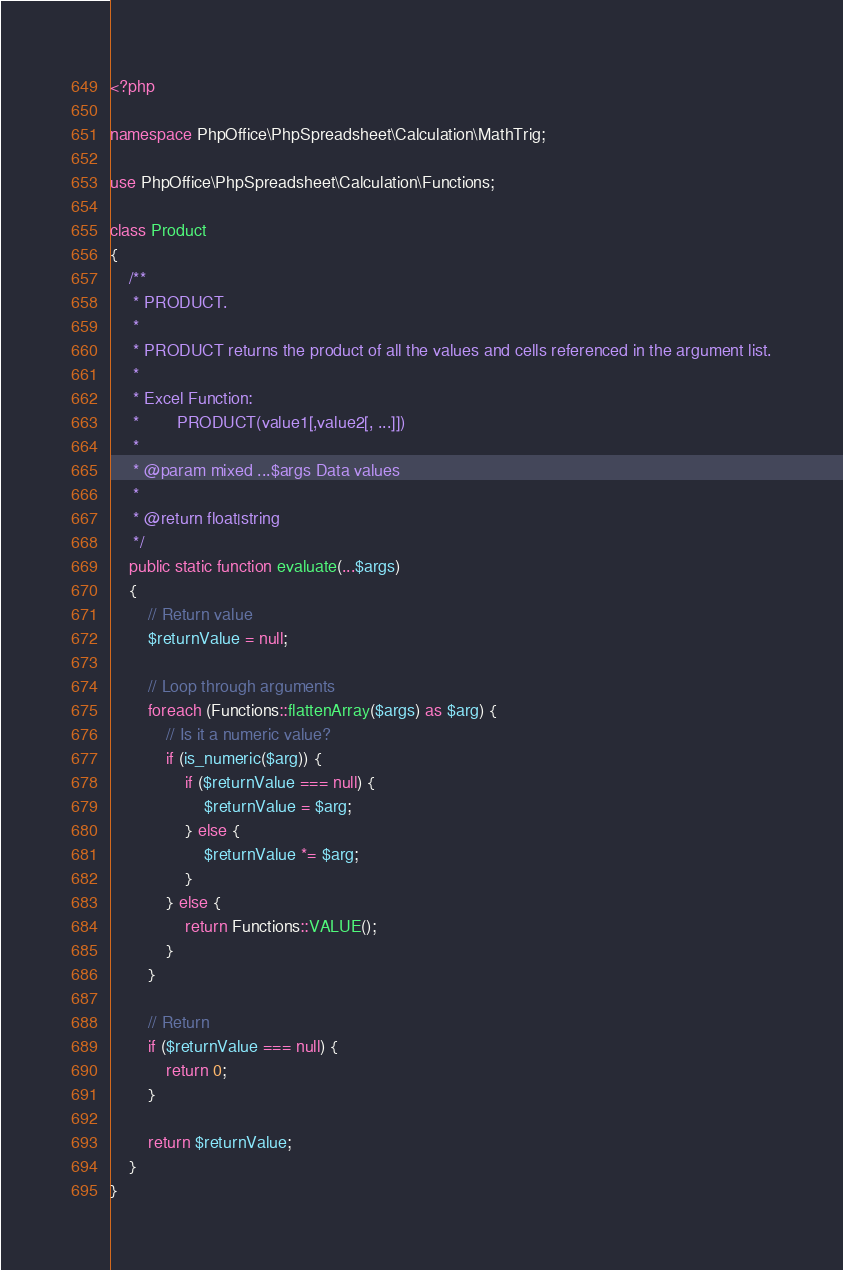<code> <loc_0><loc_0><loc_500><loc_500><_PHP_><?php

namespace PhpOffice\PhpSpreadsheet\Calculation\MathTrig;

use PhpOffice\PhpSpreadsheet\Calculation\Functions;

class Product
{
    /**
     * PRODUCT.
     *
     * PRODUCT returns the product of all the values and cells referenced in the argument list.
     *
     * Excel Function:
     *        PRODUCT(value1[,value2[, ...]])
     *
     * @param mixed ...$args Data values
     *
     * @return float|string
     */
    public static function evaluate(...$args)
    {
        // Return value
        $returnValue = null;

        // Loop through arguments
        foreach (Functions::flattenArray($args) as $arg) {
            // Is it a numeric value?
            if (is_numeric($arg)) {
                if ($returnValue === null) {
                    $returnValue = $arg;
                } else {
                    $returnValue *= $arg;
                }
            } else {
                return Functions::VALUE();
            }
        }

        // Return
        if ($returnValue === null) {
            return 0;
        }

        return $returnValue;
    }
}
</code> 